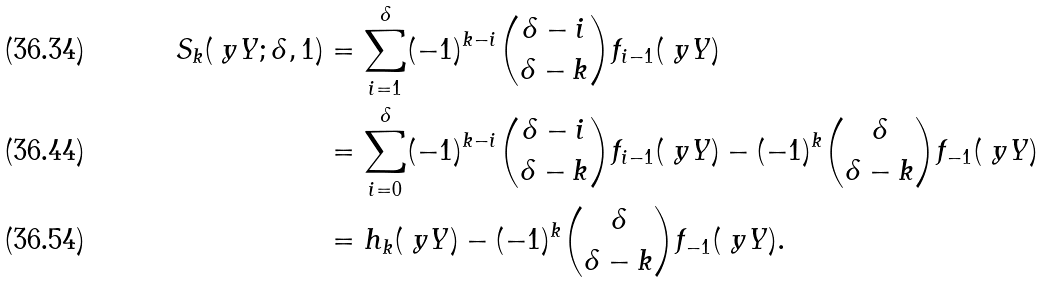Convert formula to latex. <formula><loc_0><loc_0><loc_500><loc_500>S _ { k } ( \ y Y ; \delta , 1 ) & = \sum _ { i = 1 } ^ { \delta } ( - 1 ) ^ { k - i } \binom { \delta - i } { \delta - k } f _ { i - 1 } ( \ y Y ) \\ & = \sum _ { i = 0 } ^ { \delta } ( - 1 ) ^ { k - i } \binom { \delta - i } { \delta - k } f _ { i - 1 } ( \ y Y ) - ( - 1 ) ^ { k } \binom { \delta } { \delta - k } f _ { - 1 } ( \ y Y ) \\ & = h _ { k } ( \ y Y ) - ( - 1 ) ^ { k } \binom { \delta } { \delta - k } f _ { - 1 } ( \ y Y ) .</formula> 